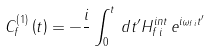<formula> <loc_0><loc_0><loc_500><loc_500>C _ { f } ^ { \left ( 1 \right ) } \left ( t \right ) = - \frac { i } { } \int _ { 0 } ^ { t } \, d t ^ { \prime } H _ { f \, i } ^ { i n t } \, e ^ { i \omega _ { f i } t ^ { \prime } }</formula> 